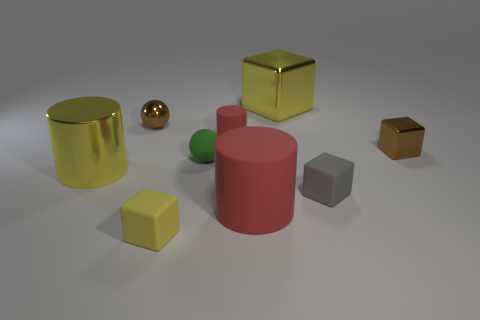Subtract all blue blocks. Subtract all blue cylinders. How many blocks are left? 4 Add 1 yellow matte things. How many objects exist? 10 Subtract all cylinders. How many objects are left? 6 Subtract 0 green blocks. How many objects are left? 9 Subtract all big blue cubes. Subtract all tiny yellow matte cubes. How many objects are left? 8 Add 2 small shiny balls. How many small shiny balls are left? 3 Add 5 cylinders. How many cylinders exist? 8 